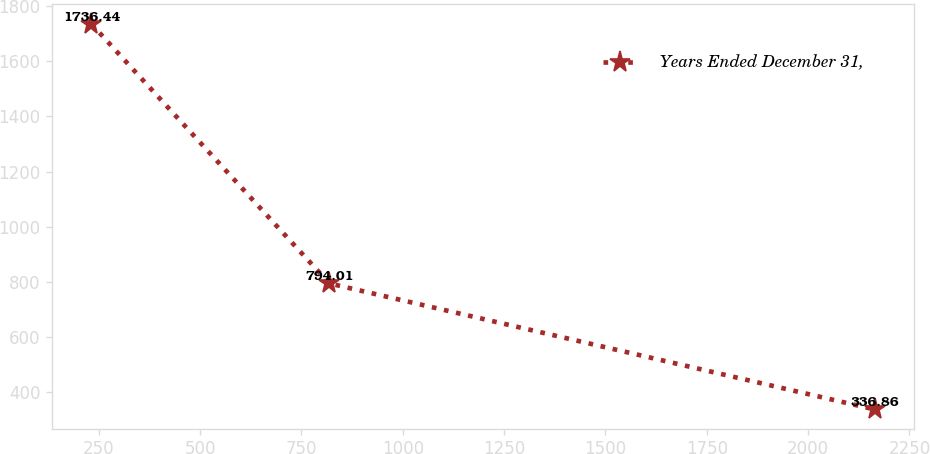Convert chart to OTSL. <chart><loc_0><loc_0><loc_500><loc_500><line_chart><ecel><fcel>Years Ended December 31,<nl><fcel>231.22<fcel>1736.44<nl><fcel>818.96<fcel>794.01<nl><fcel>2163.98<fcel>336.86<nl></chart> 